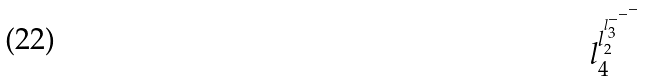<formula> <loc_0><loc_0><loc_500><loc_500>l _ { 4 } ^ { l _ { 2 } ^ { l _ { 3 } ^ { - ^ { - ^ { - } } } } }</formula> 